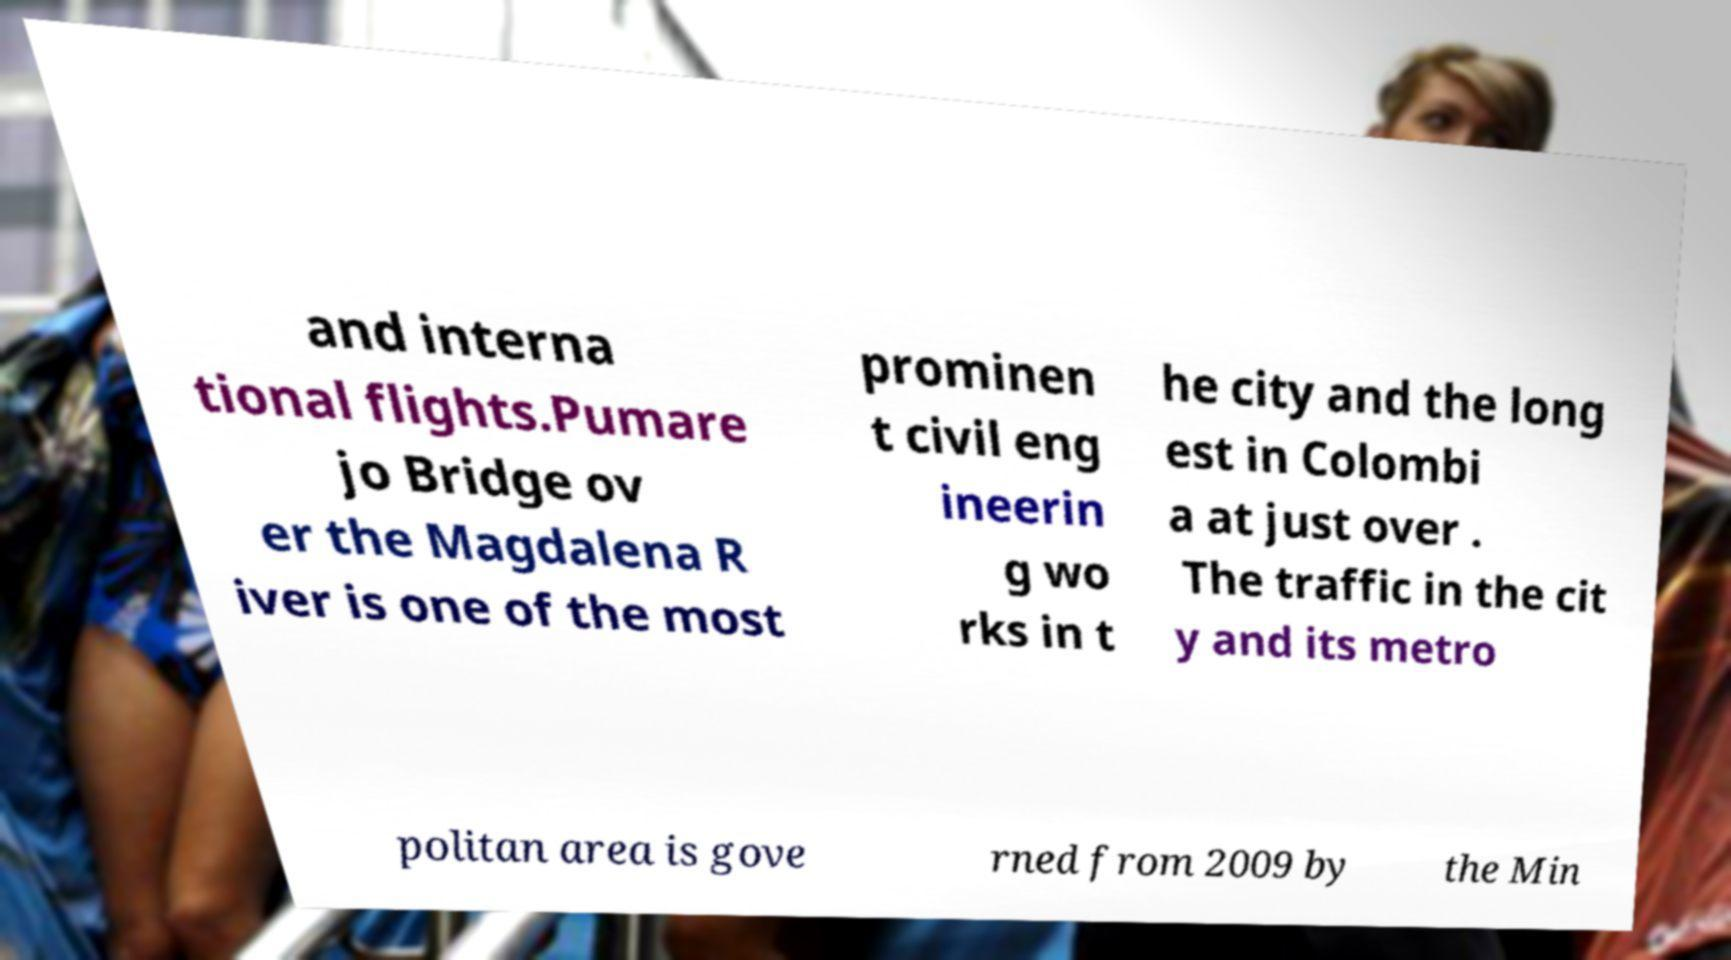Can you read and provide the text displayed in the image?This photo seems to have some interesting text. Can you extract and type it out for me? and interna tional flights.Pumare jo Bridge ov er the Magdalena R iver is one of the most prominen t civil eng ineerin g wo rks in t he city and the long est in Colombi a at just over . The traffic in the cit y and its metro politan area is gove rned from 2009 by the Min 